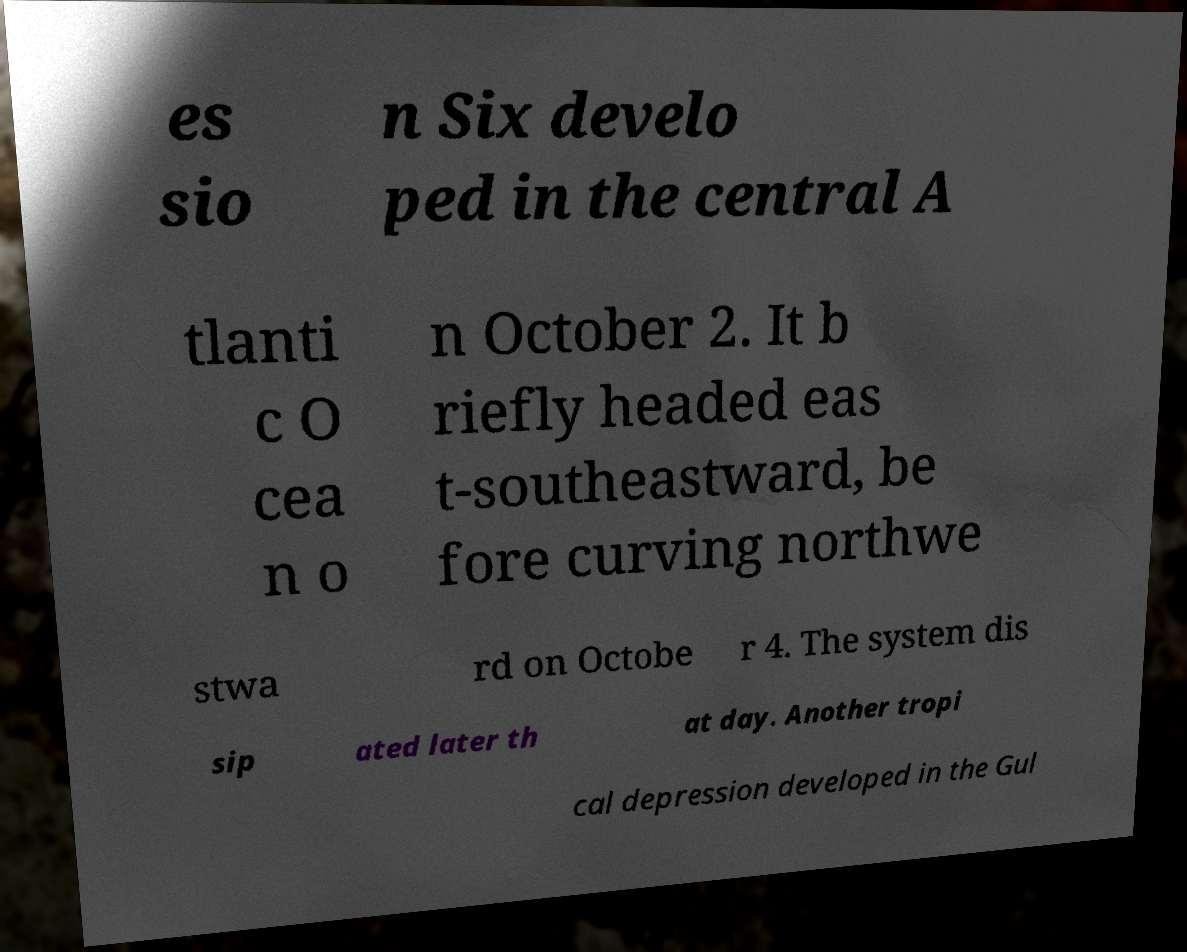Please read and relay the text visible in this image. What does it say? es sio n Six develo ped in the central A tlanti c O cea n o n October 2. It b riefly headed eas t-southeastward, be fore curving northwe stwa rd on Octobe r 4. The system dis sip ated later th at day. Another tropi cal depression developed in the Gul 